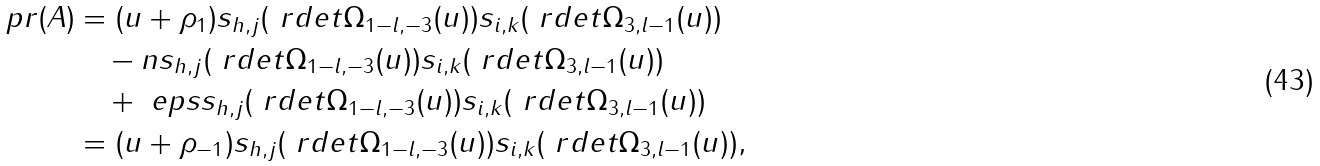Convert formula to latex. <formula><loc_0><loc_0><loc_500><loc_500>\ p r ( A ) & = ( u + \rho _ { 1 } ) s _ { h , j } ( \ r d e t \Omega _ { 1 - l , - 3 } ( u ) ) s _ { i , k } ( \ r d e t \Omega _ { 3 , l - 1 } ( u ) ) \\ & \quad - n s _ { h , j } ( \ r d e t \Omega _ { 1 - l , - 3 } ( u ) ) s _ { i , k } ( \ r d e t \Omega _ { 3 , l - 1 } ( u ) ) \\ & \quad + \ e p s s _ { h , j } ( \ r d e t \Omega _ { 1 - l , - 3 } ( u ) ) s _ { i , k } ( \ r d e t \Omega _ { 3 , l - 1 } ( u ) ) \\ & = ( u + \rho _ { - 1 } ) s _ { h , j } ( \ r d e t \Omega _ { 1 - l , - 3 } ( u ) ) s _ { i , k } ( \ r d e t \Omega _ { 3 , l - 1 } ( u ) ) ,</formula> 